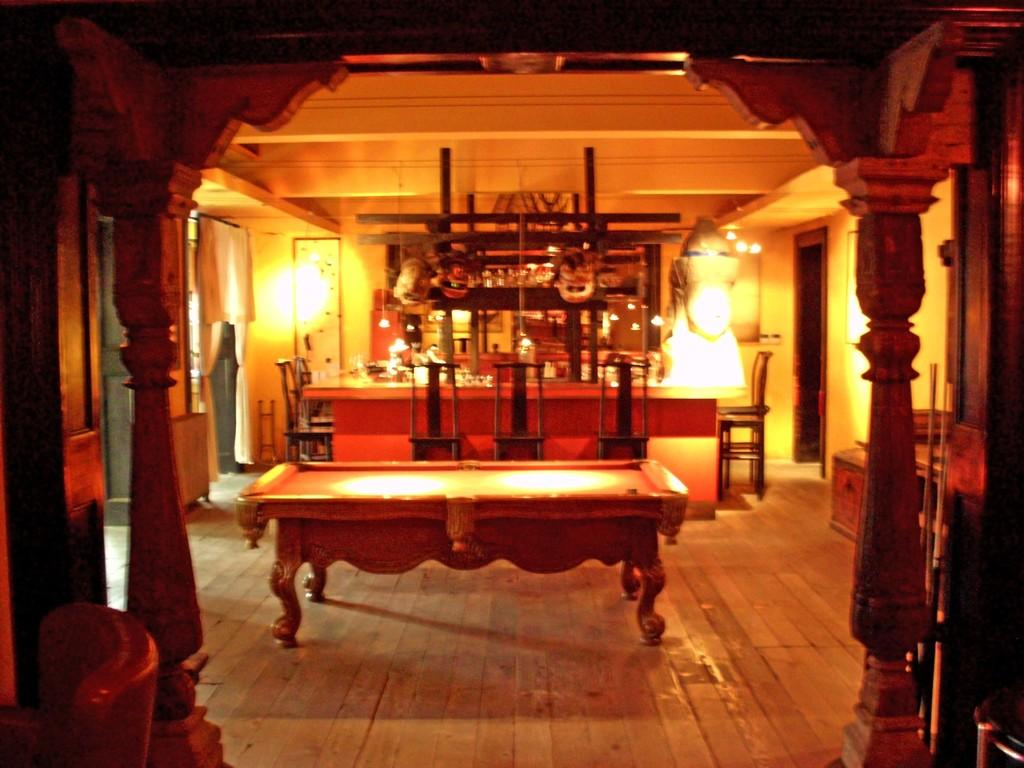What type of space is depicted in the image? There is a room in the image. What furniture is present in the room? There are tables and chairs in the room. What is used for illumination in the room? There are lights in the room. What type of window treatment is present in the room? There are curtains in the room. What is the memory capacity of the town in the image? There is no town present in the image, so it is not possible to determine its memory capacity. 